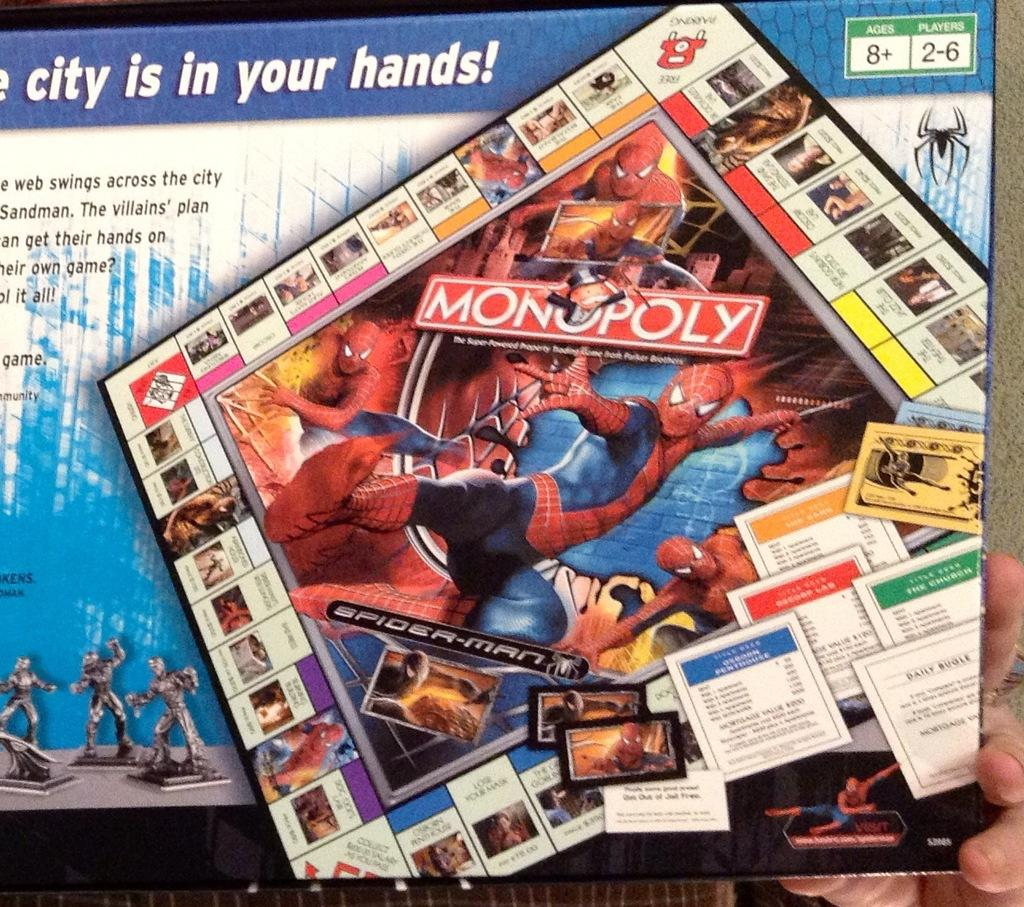What is being held in the person's hand in the image? There is a person's hand holding a box in the image. What is inside the box? The box contains a Monopoly game. What design is featured on the box? There are Spider-Man pictures on the box. What colors can be seen on the box? The box is blue, black, and white in color. What type of chin is visible on the Monopoly game in the image? There is no chin present in the image; it features a person's hand holding a box with a Monopoly game inside. 